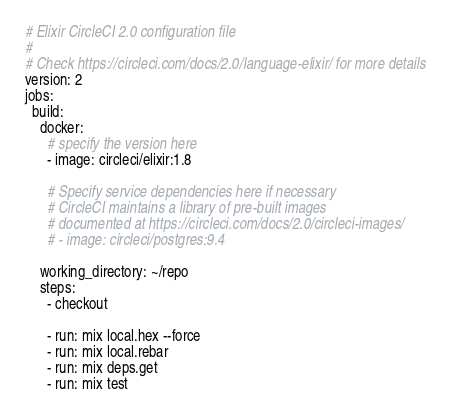<code> <loc_0><loc_0><loc_500><loc_500><_YAML_># Elixir CircleCI 2.0 configuration file
#
# Check https://circleci.com/docs/2.0/language-elixir/ for more details
version: 2
jobs:
  build:
    docker:
      # specify the version here
      - image: circleci/elixir:1.8

      # Specify service dependencies here if necessary
      # CircleCI maintains a library of pre-built images
      # documented at https://circleci.com/docs/2.0/circleci-images/
      # - image: circleci/postgres:9.4

    working_directory: ~/repo
    steps:
      - checkout

      - run: mix local.hex --force
      - run: mix local.rebar
      - run: mix deps.get
      - run: mix test
</code> 